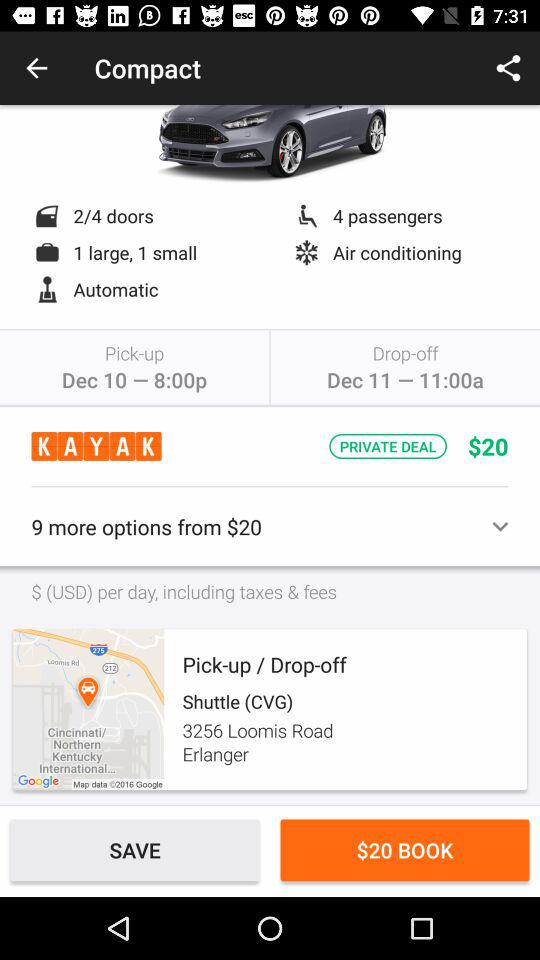What is the drop off time? The drop-off time is 11:00 a.m. 